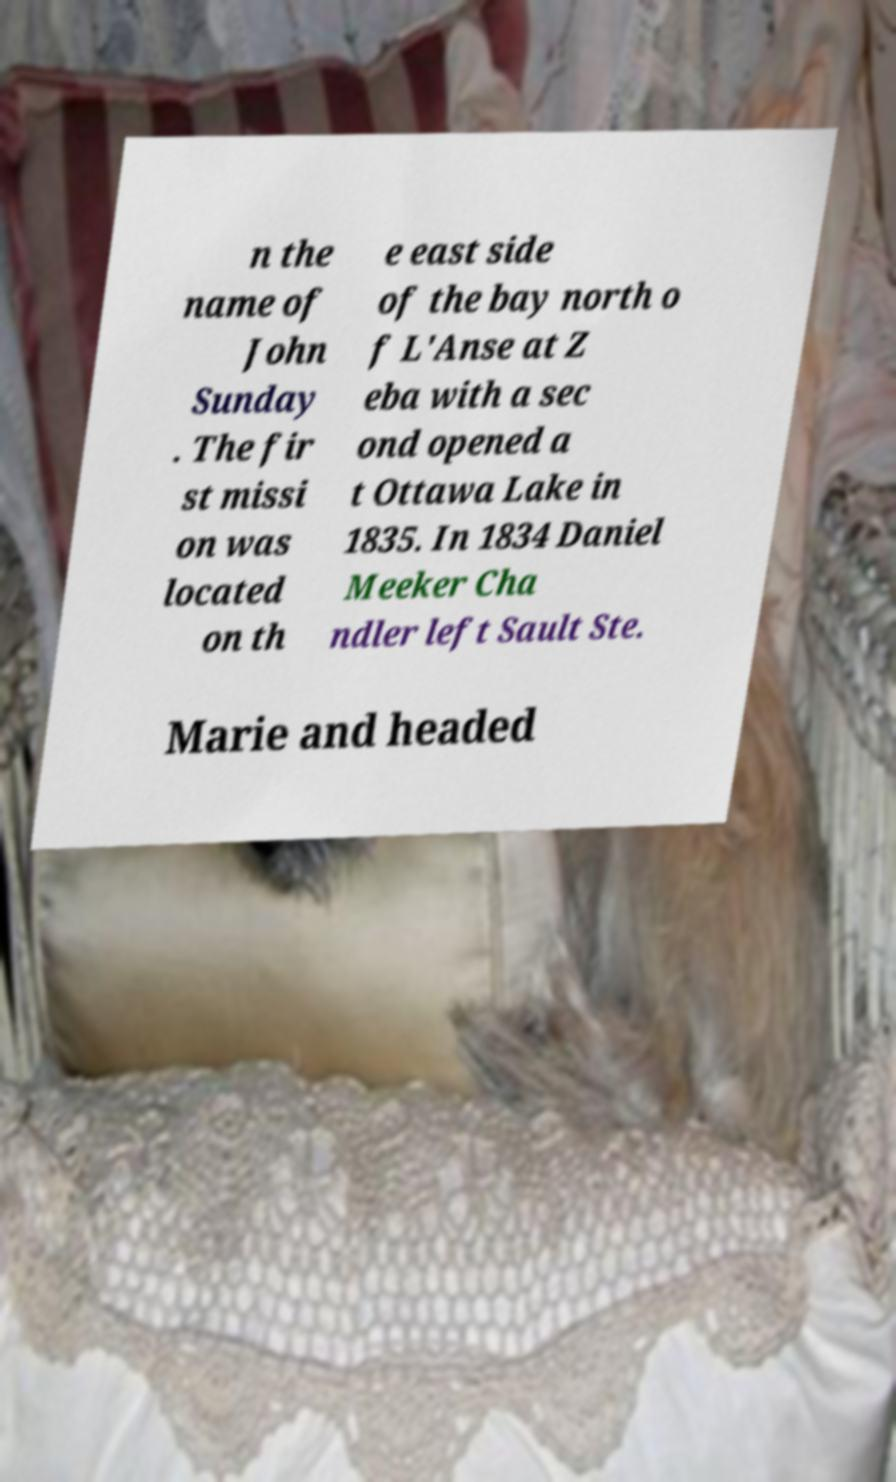There's text embedded in this image that I need extracted. Can you transcribe it verbatim? n the name of John Sunday . The fir st missi on was located on th e east side of the bay north o f L'Anse at Z eba with a sec ond opened a t Ottawa Lake in 1835. In 1834 Daniel Meeker Cha ndler left Sault Ste. Marie and headed 